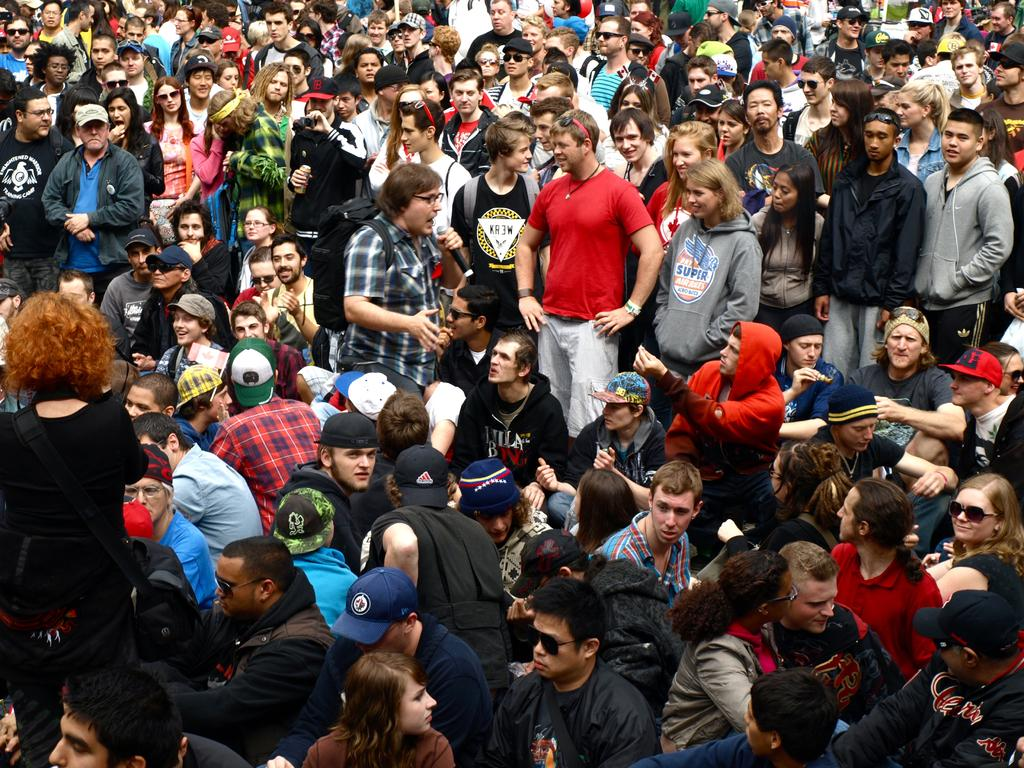What is the main subject of the image? The main subject of the image is a group of persons. Where are the standing persons located in the image? The group of standing persons is located at the top of the image. Where are the sitting persons located in the image? The group of sitting persons is located at the bottom of the image. What type of seed is being planted by the group in the image? There is no seed or planting activity depicted in the image; it only shows a group of standing and sitting persons. 